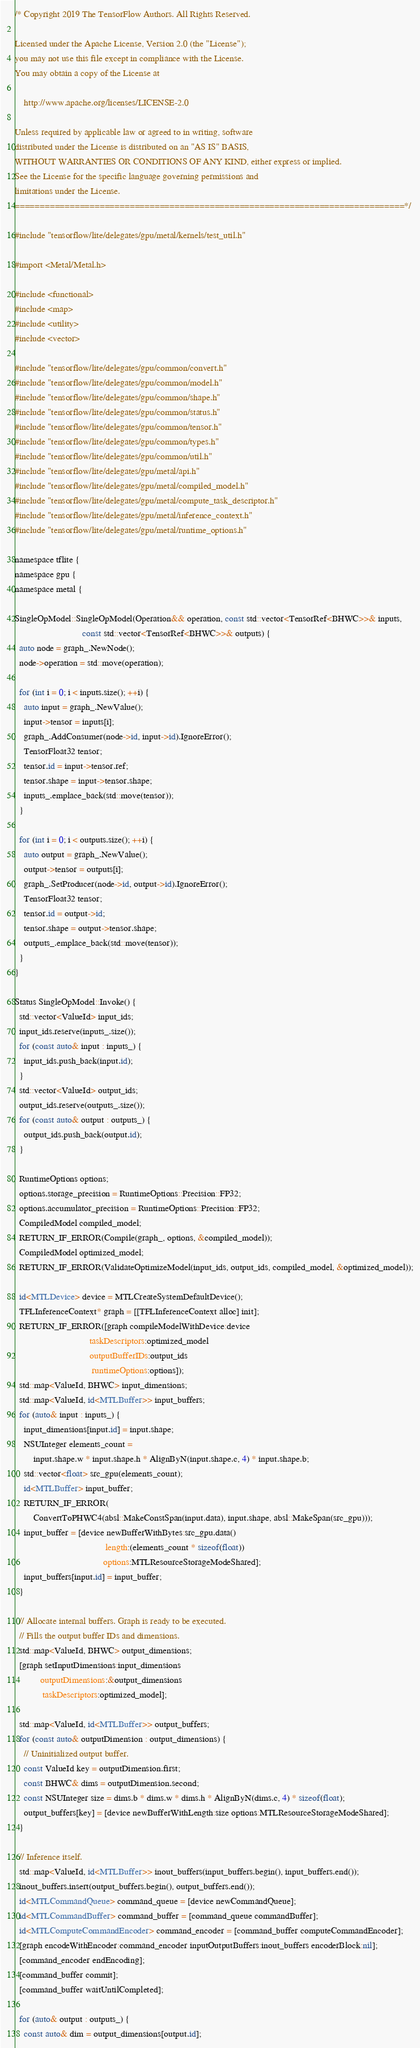<code> <loc_0><loc_0><loc_500><loc_500><_ObjectiveC_>/* Copyright 2019 The TensorFlow Authors. All Rights Reserved.

Licensed under the Apache License, Version 2.0 (the "License");
you may not use this file except in compliance with the License.
You may obtain a copy of the License at

    http://www.apache.org/licenses/LICENSE-2.0

Unless required by applicable law or agreed to in writing, software
distributed under the License is distributed on an "AS IS" BASIS,
WITHOUT WARRANTIES OR CONDITIONS OF ANY KIND, either express or implied.
See the License for the specific language governing permissions and
limitations under the License.
==============================================================================*/

#include "tensorflow/lite/delegates/gpu/metal/kernels/test_util.h"

#import <Metal/Metal.h>

#include <functional>
#include <map>
#include <utility>
#include <vector>

#include "tensorflow/lite/delegates/gpu/common/convert.h"
#include "tensorflow/lite/delegates/gpu/common/model.h"
#include "tensorflow/lite/delegates/gpu/common/shape.h"
#include "tensorflow/lite/delegates/gpu/common/status.h"
#include "tensorflow/lite/delegates/gpu/common/tensor.h"
#include "tensorflow/lite/delegates/gpu/common/types.h"
#include "tensorflow/lite/delegates/gpu/common/util.h"
#include "tensorflow/lite/delegates/gpu/metal/api.h"
#include "tensorflow/lite/delegates/gpu/metal/compiled_model.h"
#include "tensorflow/lite/delegates/gpu/metal/compute_task_descriptor.h"
#include "tensorflow/lite/delegates/gpu/metal/inference_context.h"
#include "tensorflow/lite/delegates/gpu/metal/runtime_options.h"

namespace tflite {
namespace gpu {
namespace metal {

SingleOpModel::SingleOpModel(Operation&& operation, const std::vector<TensorRef<BHWC>>& inputs,
                             const std::vector<TensorRef<BHWC>>& outputs) {
  auto node = graph_.NewNode();
  node->operation = std::move(operation);

  for (int i = 0; i < inputs.size(); ++i) {
    auto input = graph_.NewValue();
    input->tensor = inputs[i];
    graph_.AddConsumer(node->id, input->id).IgnoreError();
    TensorFloat32 tensor;
    tensor.id = input->tensor.ref;
    tensor.shape = input->tensor.shape;
    inputs_.emplace_back(std::move(tensor));
  }

  for (int i = 0; i < outputs.size(); ++i) {
    auto output = graph_.NewValue();
    output->tensor = outputs[i];
    graph_.SetProducer(node->id, output->id).IgnoreError();
    TensorFloat32 tensor;
    tensor.id = output->id;
    tensor.shape = output->tensor.shape;
    outputs_.emplace_back(std::move(tensor));
  }
}

Status SingleOpModel::Invoke() {
  std::vector<ValueId> input_ids;
  input_ids.reserve(inputs_.size());
  for (const auto& input : inputs_) {
    input_ids.push_back(input.id);
  }
  std::vector<ValueId> output_ids;
  output_ids.reserve(outputs_.size());
  for (const auto& output : outputs_) {
    output_ids.push_back(output.id);
  }

  RuntimeOptions options;
  options.storage_precision = RuntimeOptions::Precision::FP32;
  options.accumulator_precision = RuntimeOptions::Precision::FP32;
  CompiledModel compiled_model;
  RETURN_IF_ERROR(Compile(graph_, options, &compiled_model));
  CompiledModel optimized_model;
  RETURN_IF_ERROR(ValidateOptimizeModel(input_ids, output_ids, compiled_model, &optimized_model));

  id<MTLDevice> device = MTLCreateSystemDefaultDevice();
  TFLInferenceContext* graph = [[TFLInferenceContext alloc] init];
  RETURN_IF_ERROR([graph compileModelWithDevice:device
                                taskDescriptors:optimized_model
                                outputBufferIDs:output_ids
                                 runtimeOptions:options]);
  std::map<ValueId, BHWC> input_dimensions;
  std::map<ValueId, id<MTLBuffer>> input_buffers;
  for (auto& input : inputs_) {
    input_dimensions[input.id] = input.shape;
    NSUInteger elements_count =
        input.shape.w * input.shape.h * AlignByN(input.shape.c, 4) * input.shape.b;
    std::vector<float> src_gpu(elements_count);
    id<MTLBuffer> input_buffer;
    RETURN_IF_ERROR(
        ConvertToPHWC4(absl::MakeConstSpan(input.data), input.shape, absl::MakeSpan(src_gpu)));
    input_buffer = [device newBufferWithBytes:src_gpu.data()
                                       length:(elements_count * sizeof(float))
                                      options:MTLResourceStorageModeShared];
    input_buffers[input.id] = input_buffer;
  }

  // Allocate internal buffers. Graph is ready to be executed.
  // Fills the output buffer IDs and dimensions.
  std::map<ValueId, BHWC> output_dimensions;
  [graph setInputDimensions:input_dimensions
           outputDimensions:&output_dimensions
            taskDescriptors:optimized_model];

  std::map<ValueId, id<MTLBuffer>> output_buffers;
  for (const auto& outputDimension : output_dimensions) {
    // Uninitialized output buffer.
    const ValueId key = outputDimension.first;
    const BHWC& dims = outputDimension.second;
    const NSUInteger size = dims.b * dims.w * dims.h * AlignByN(dims.c, 4) * sizeof(float);
    output_buffers[key] = [device newBufferWithLength:size options:MTLResourceStorageModeShared];
  }

  // Inference itself.
  std::map<ValueId, id<MTLBuffer>> inout_buffers(input_buffers.begin(), input_buffers.end());
  inout_buffers.insert(output_buffers.begin(), output_buffers.end());
  id<MTLCommandQueue> command_queue = [device newCommandQueue];
  id<MTLCommandBuffer> command_buffer = [command_queue commandBuffer];
  id<MTLComputeCommandEncoder> command_encoder = [command_buffer computeCommandEncoder];
  [graph encodeWithEncoder:command_encoder inputOutputBuffers:inout_buffers encoderBlock:nil];
  [command_encoder endEncoding];
  [command_buffer commit];
  [command_buffer waitUntilCompleted];

  for (auto& output : outputs_) {
    const auto& dim = output_dimensions[output.id];</code> 